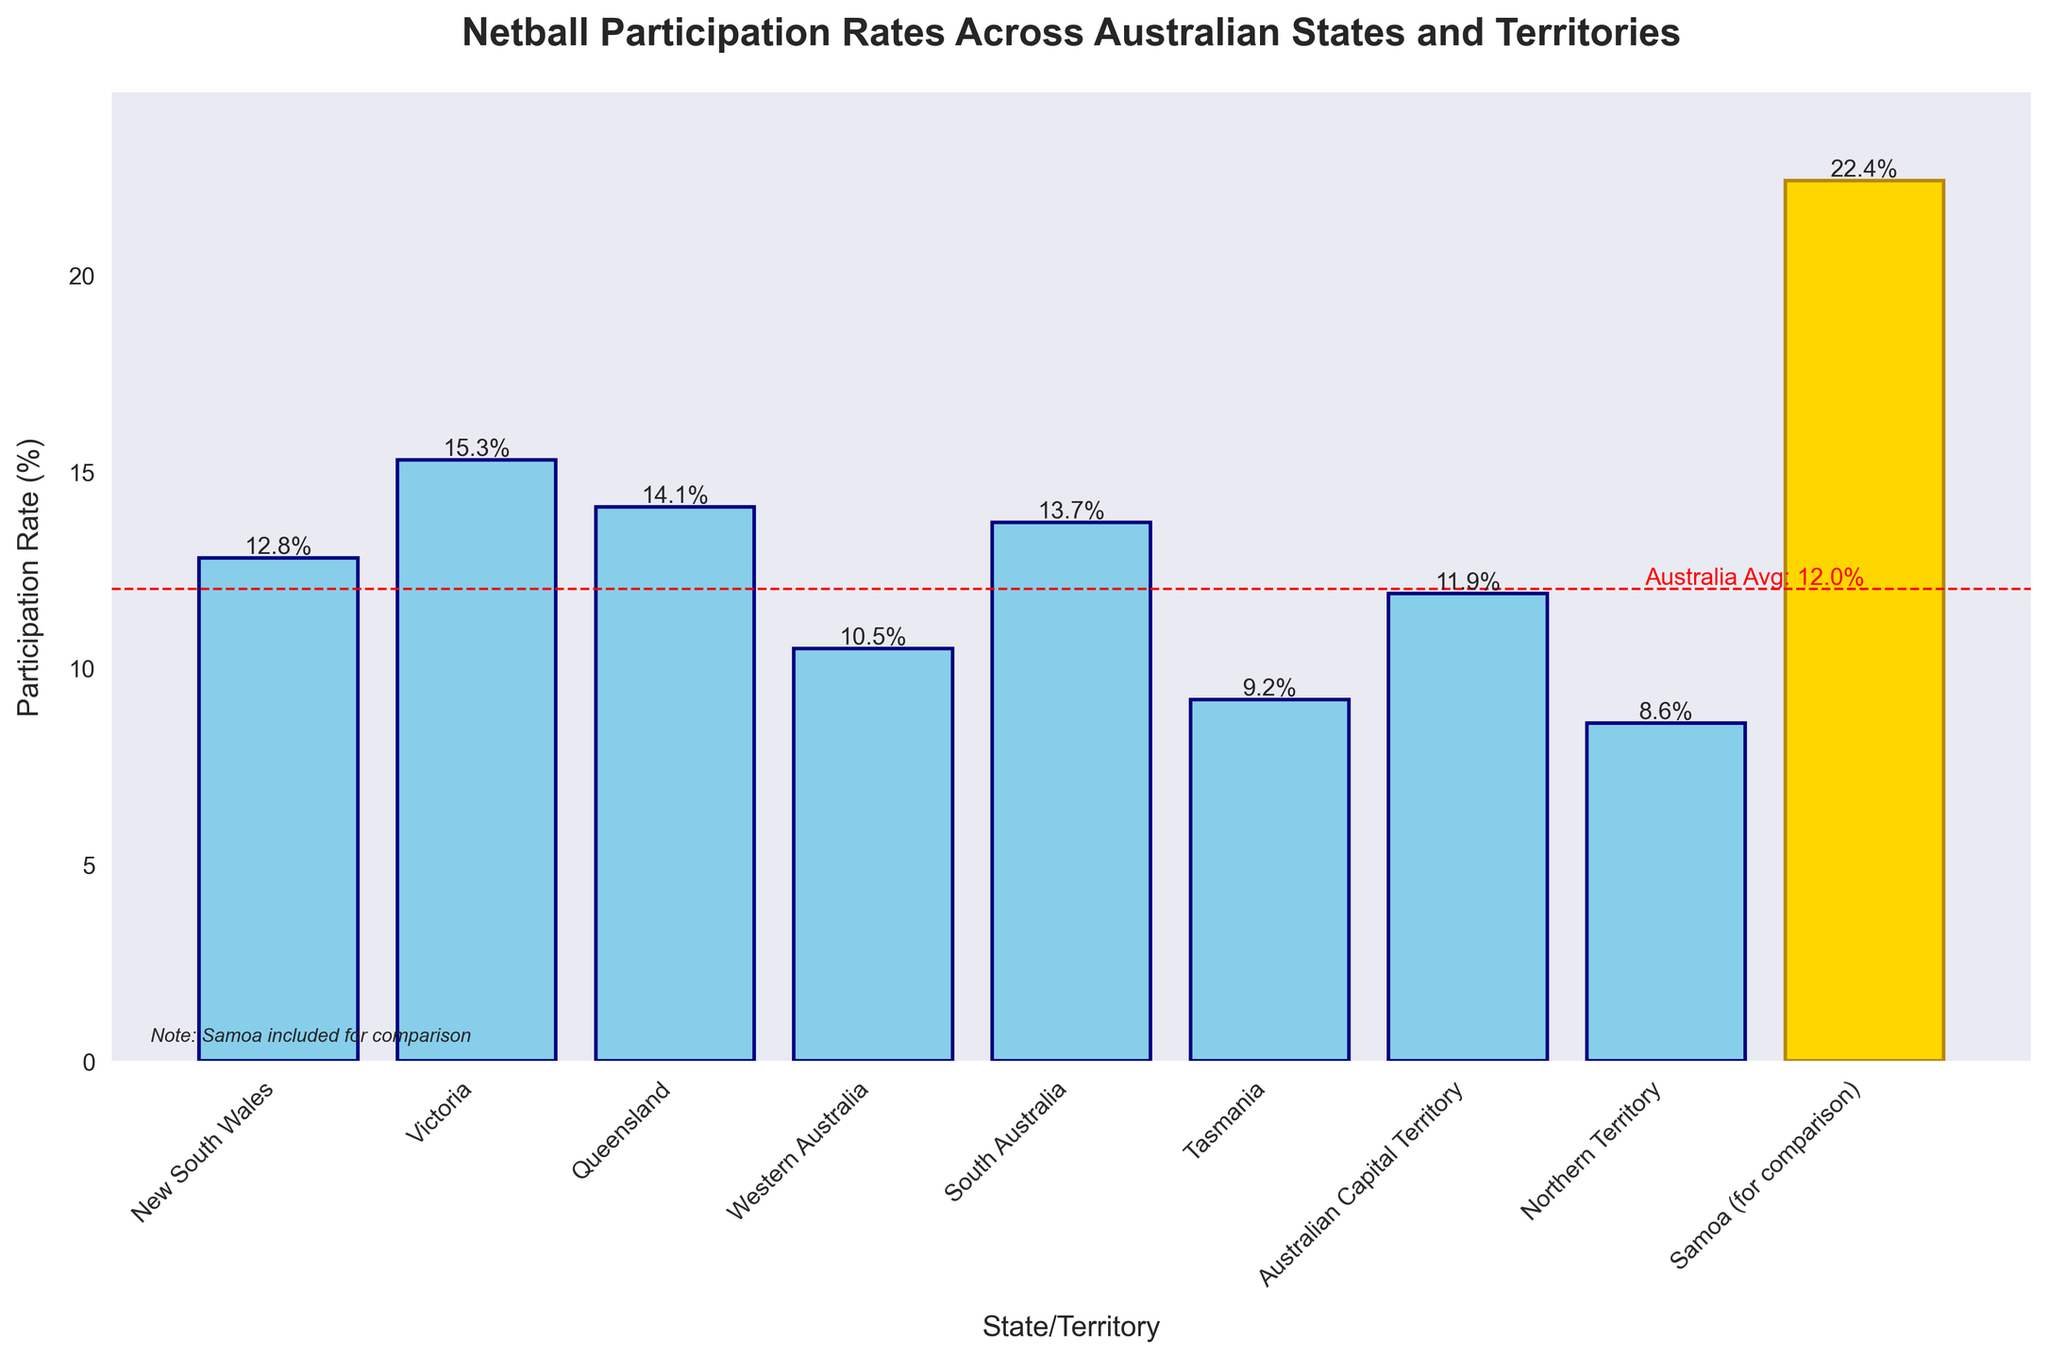Which state or territory has the highest netball participation rate? According to the bar chart, Victoria has the highest netball participation rate among the states and territories.
Answer: Victoria How does the participation rate in Queensland compare to that in Western Australia? Queensland has a participation rate of 14.1%, while Western Australia has a rate of 10.5%. Queensland's rate is higher by 3.6%.
Answer: Queensland's rate is higher by 3.6% Is Tasmania's participation rate above or below the national average? The national average participation rate can be derived by excluding Samoa and averaging the rates of the other states and territories. The average rate is about 12.3%. Tasmania's rate is 9.2%, which is below the national average.
Answer: Below What is the difference between the netball participation rates in South Australia and the Australian Capital Territory? South Australia has a participation rate of 13.7%, whereas the Australian Capital Territory has a rate of 11.9%. The difference is 13.7% - 11.9% = 1.8%.
Answer: 1.8% What is the average participation rate across all Australian states and territories (excluding Samoa)? To find the average, sum the participation rates of all Australian states and territories and divide by the number of states and territories. The sum is (12.8 + 15.3 + 14.1 + 10.5 + 13.7 + 9.2 + 11.9 + 8.6) = 96.1. There are 8 datapoints. Hence, the average is 96.1 / 8 = 12.0%.
Answer: 12.0% Which state or territory has the lowest netball participation rate? According to the bar chart, the Northern Territory shows the lowest netball participation rate among states and territories.
Answer: Northern Territory How much higher is Samoa's netball participation rate compared to the Australian Capital Territory? Samoa has a participation rate of 22.4%, and the Australian Capital Territory has a rate of 11.9%. The difference is 22.4% - 11.9% = 10.5%.
Answer: 10.5% What color represents Samoa in the bar chart and why? Samoa is represented by the color gold in the bar chart to differentiate it from the Australian states and territories for comparison.
Answer: Gold Which two regions have the closest netball participation rates? To determine this, compare the rates: 12.8 (NSW), 15.3 (VIC), 14.1 (QLD), 10.5 (WA), 13.7 (SA), 9.2 (TAS), 11.9 (ACT), and 8.6 (NT). The closest pair is South Australia (13.7%) and Queensland (14.1%), with a difference of 0.4%.
Answer: Queensland and South Australia Which state or territory's bar height is below the indicated national average line? Tas, WA, and NT have bars below the indicated national average line of around 12.0%.
Answer: Tasmania, Western Australia, Northern Territory 